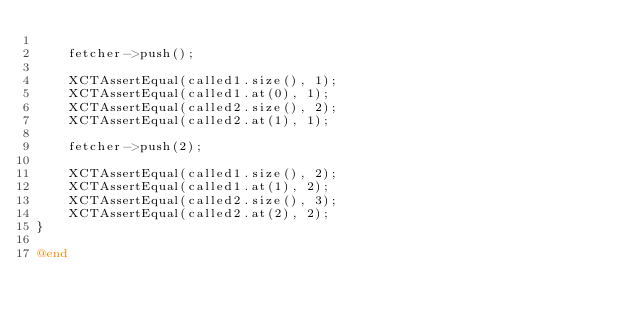Convert code to text. <code><loc_0><loc_0><loc_500><loc_500><_ObjectiveC_>
    fetcher->push();

    XCTAssertEqual(called1.size(), 1);
    XCTAssertEqual(called1.at(0), 1);
    XCTAssertEqual(called2.size(), 2);
    XCTAssertEqual(called2.at(1), 1);

    fetcher->push(2);

    XCTAssertEqual(called1.size(), 2);
    XCTAssertEqual(called1.at(1), 2);
    XCTAssertEqual(called2.size(), 3);
    XCTAssertEqual(called2.at(2), 2);
}

@end
</code> 